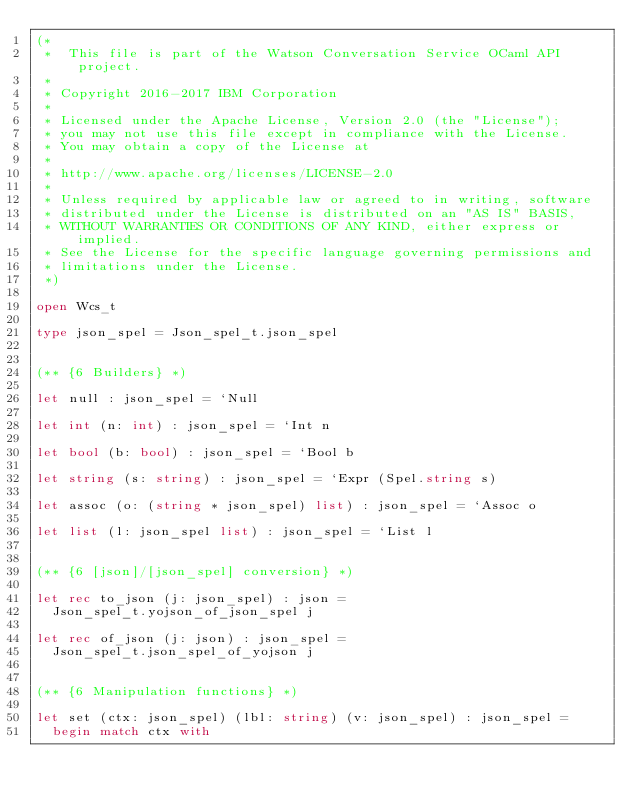Convert code to text. <code><loc_0><loc_0><loc_500><loc_500><_OCaml_>(*
 *  This file is part of the Watson Conversation Service OCaml API project.
 *
 * Copyright 2016-2017 IBM Corporation
 *
 * Licensed under the Apache License, Version 2.0 (the "License");
 * you may not use this file except in compliance with the License.
 * You may obtain a copy of the License at
 *
 * http://www.apache.org/licenses/LICENSE-2.0
 *
 * Unless required by applicable law or agreed to in writing, software
 * distributed under the License is distributed on an "AS IS" BASIS,
 * WITHOUT WARRANTIES OR CONDITIONS OF ANY KIND, either express or implied.
 * See the License for the specific language governing permissions and
 * limitations under the License.
 *)

open Wcs_t

type json_spel = Json_spel_t.json_spel


(** {6 Builders} *)

let null : json_spel = `Null

let int (n: int) : json_spel = `Int n

let bool (b: bool) : json_spel = `Bool b

let string (s: string) : json_spel = `Expr (Spel.string s)

let assoc (o: (string * json_spel) list) : json_spel = `Assoc o

let list (l: json_spel list) : json_spel = `List l


(** {6 [json]/[json_spel] conversion} *)

let rec to_json (j: json_spel) : json =
  Json_spel_t.yojson_of_json_spel j

let rec of_json (j: json) : json_spel =
  Json_spel_t.json_spel_of_yojson j


(** {6 Manipulation functions} *)

let set (ctx: json_spel) (lbl: string) (v: json_spel) : json_spel =
  begin match ctx with</code> 